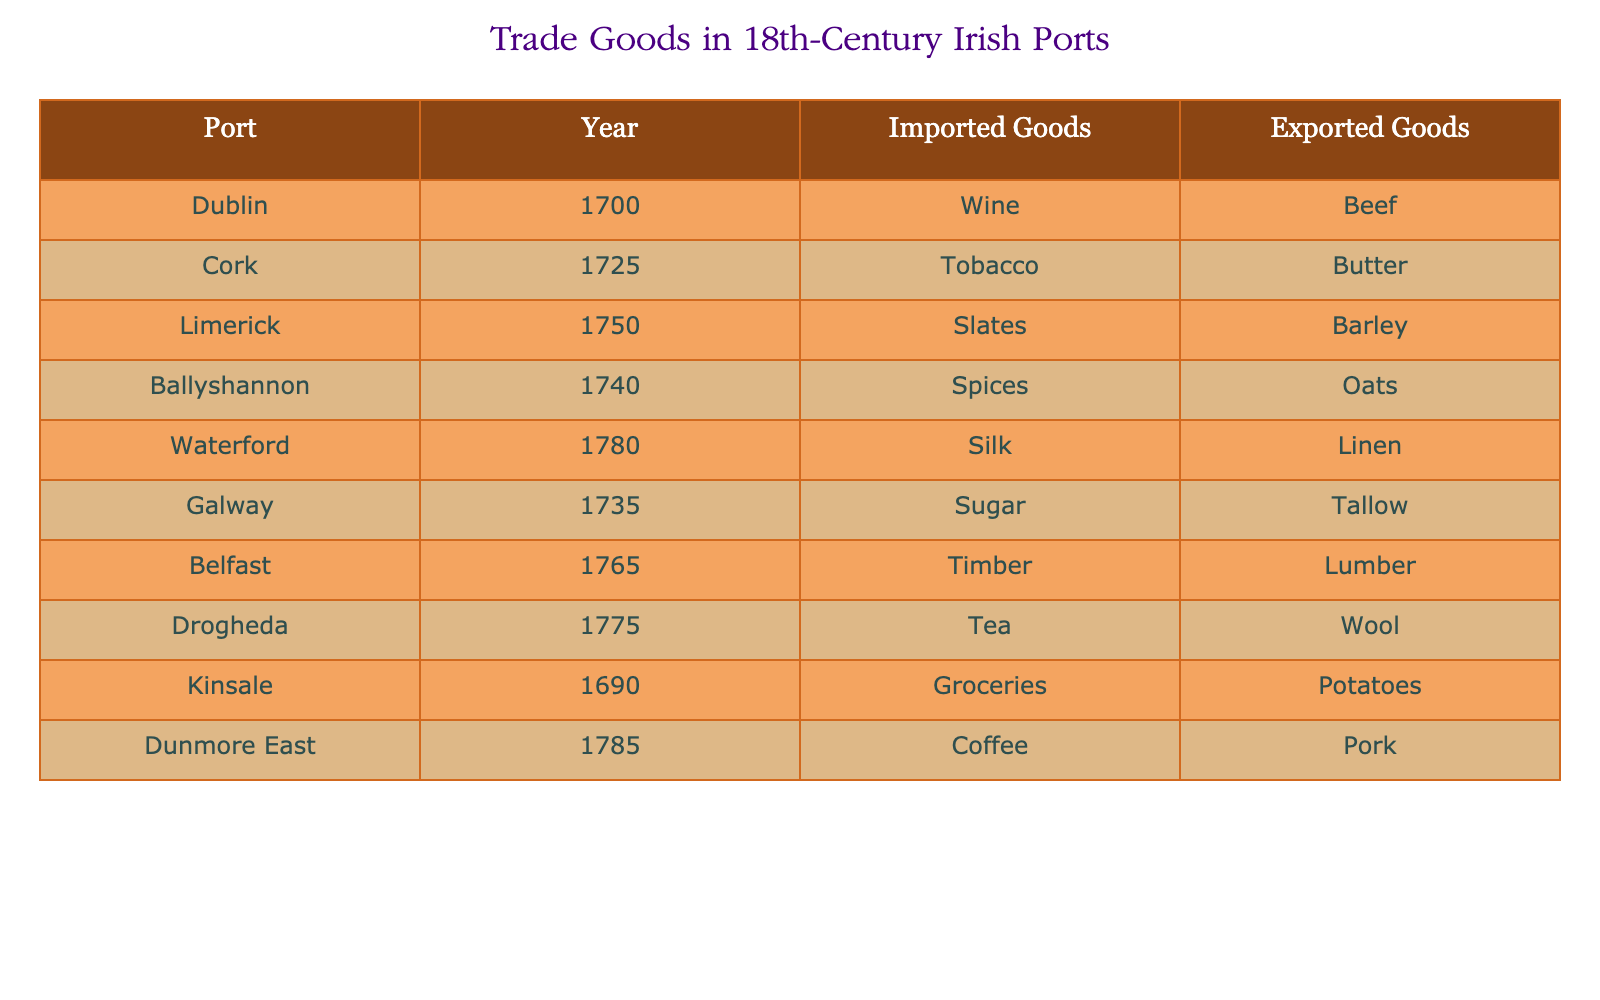What goods were exported from Dublin in 1700? The table indicates that Dublin exported beef in the year 1700. To find this, I simply look at the row corresponding to Dublin and the year 1700, where the exported goods are specified clearly.
Answer: Beef Which port imported spices in 1740? According to the table, Ballyshannon is the port that imported spices in the year 1740. This is determined by locating the row for the year 1740 and checking the imported goods column.
Answer: Ballyshannon How many unique goods were imported across all ports listed? The unique imported goods are wine, tobacco, slates, spices, silk, sugar, timber, tea, groceries, and coffee. By reviewing each unique entry in the imported goods column, I count a total of 10 different items without repetition.
Answer: 10 Was tea imported by more than one port? The data shows that tea was imported only by Drogheda; no other port in the table lists tea under imported goods. Thus, the answer is no, as I verified the imported goods for each port.
Answer: No Which port had both the highest value and the lowest value of exported goods mentioned in the table? For the highest value, I identify for each port the exported goods and find that butter (Cork) is relatively valued when compared to others. Then for the lowest, I look at the context of the items and determine that tallow (Galway) likely ranks lower. Thus, Cork exported butter and Galway exported tallow. The maximum is butter, and the minimum is tallow.
Answer: Cork for highest, Galway for lowest What is the difference in the years of import and export for coffee and pork? Coffee was imported in 1785, and pork was exported the same year, so both happened in 1785. The difference between the years of import and export for these goods is calculated by (1785 - 1785) which results in 0.
Answer: 0 Is it true that Galway was the only port that exported tallow in the 18th century? Checking the table, it indicates that only Galway exported tallow and no other port has been listed with that item as exported. Hence, this statement is verified as true based on the row information.
Answer: Yes Which port imported goods in the year 1780, and what were those goods? Waterford is the port that imported goods in 1780, specifically silk. This is found by searching for the row for the year 1780 in the table and checking the corresponding imported goods.
Answer: Waterford, Silk Count the number of ports that exported goods made from animal products. The exported goods made from animal products mentioned in the table include beef, butter, barley, oats, tallow, wool, and pork. Examining each export category, I find that ports such as Dublin (beef), Cork (butter), Limerick (barley), Ballyshannon (oats), Galway (tallow), Drogheda (wool), and Dunmore East (pork) all fit this classification. This adds up to 7 ports.
Answer: 7 